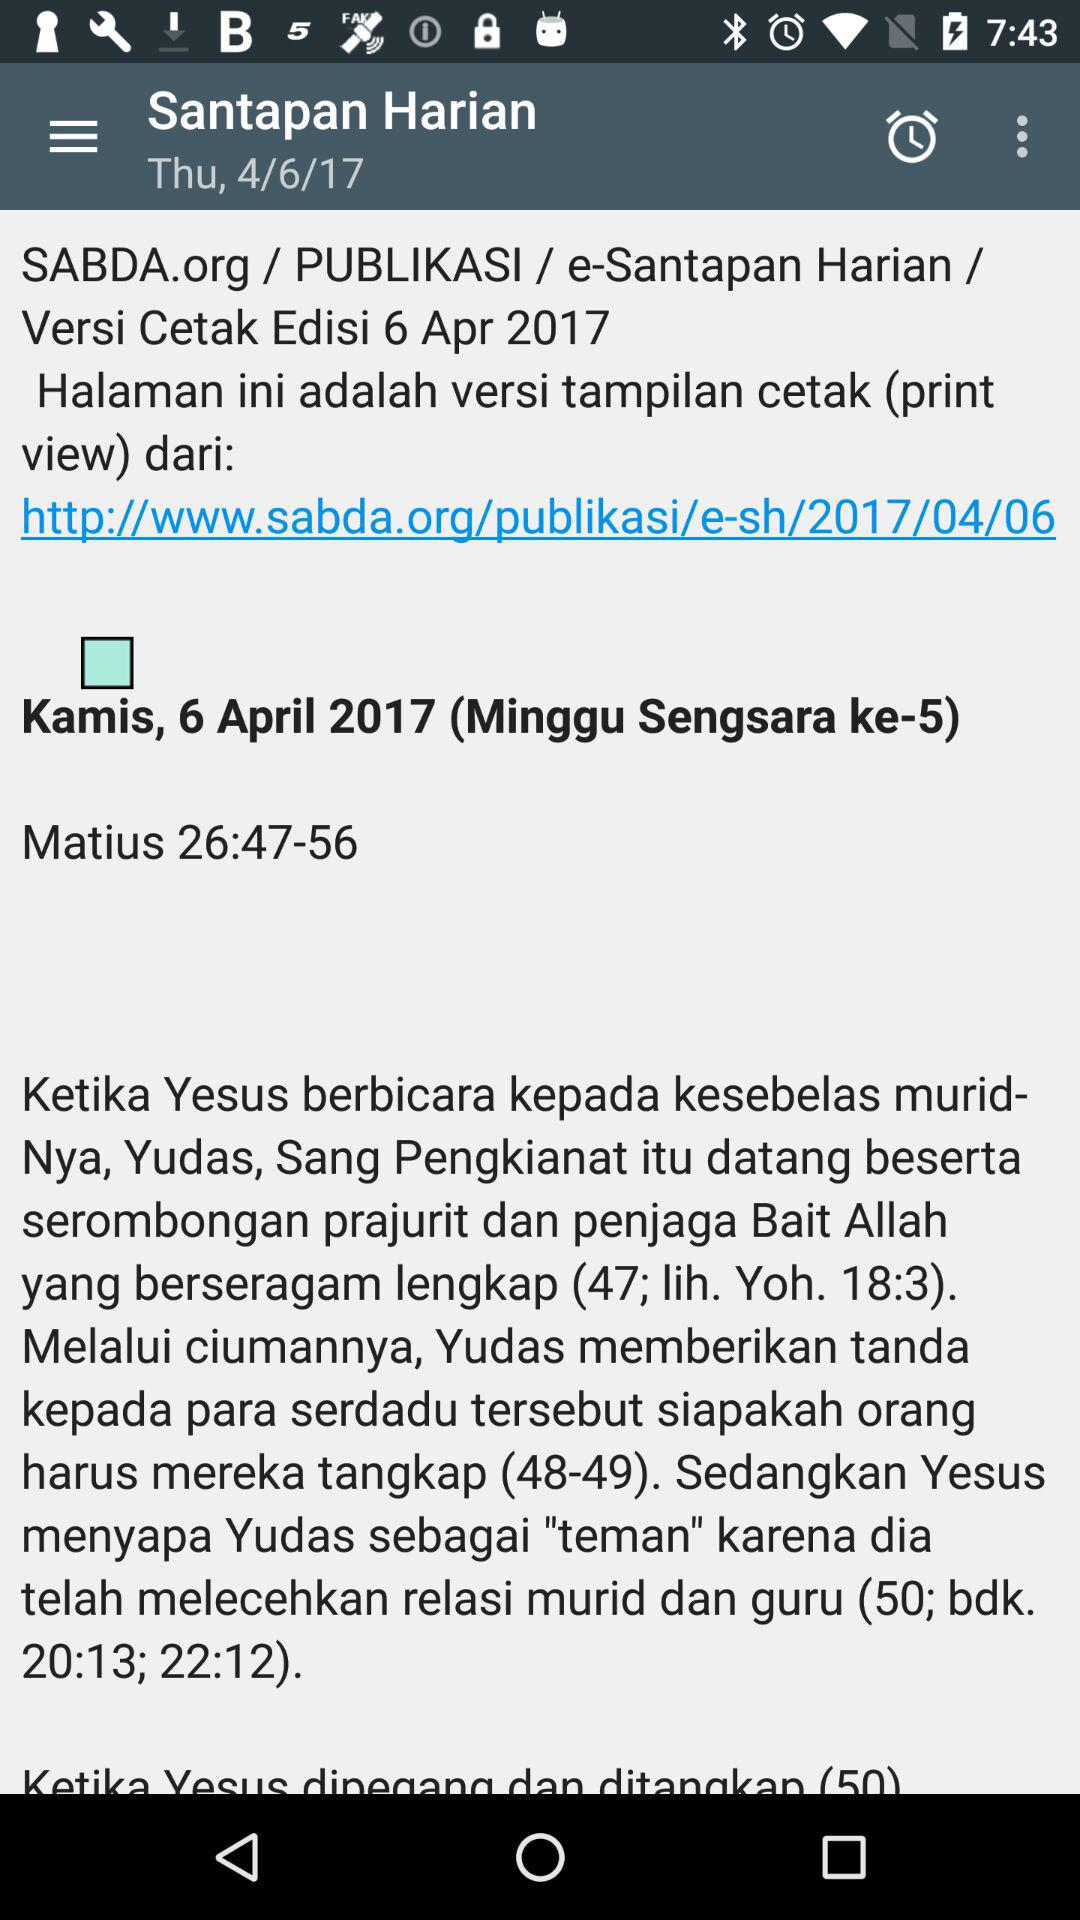What is the mentioned date? The mentioned date is Thursday, April 6, 2017. 